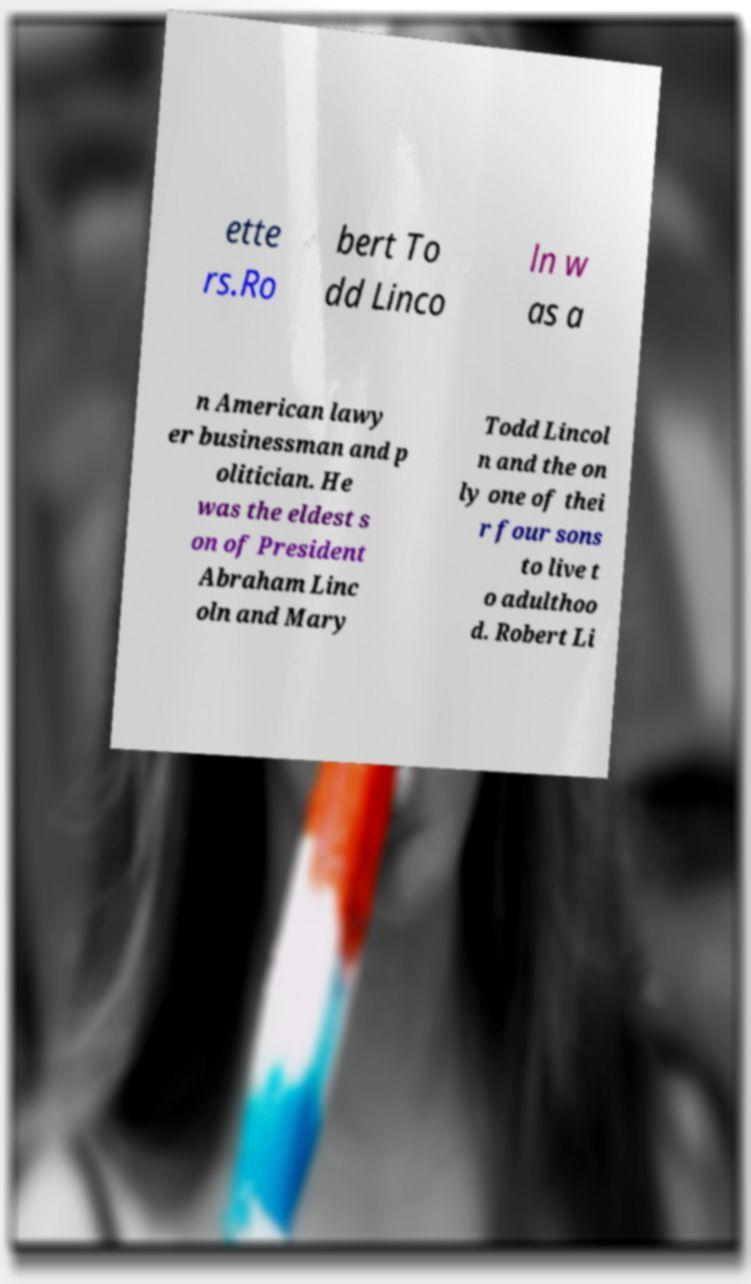For documentation purposes, I need the text within this image transcribed. Could you provide that? ette rs.Ro bert To dd Linco ln w as a n American lawy er businessman and p olitician. He was the eldest s on of President Abraham Linc oln and Mary Todd Lincol n and the on ly one of thei r four sons to live t o adulthoo d. Robert Li 